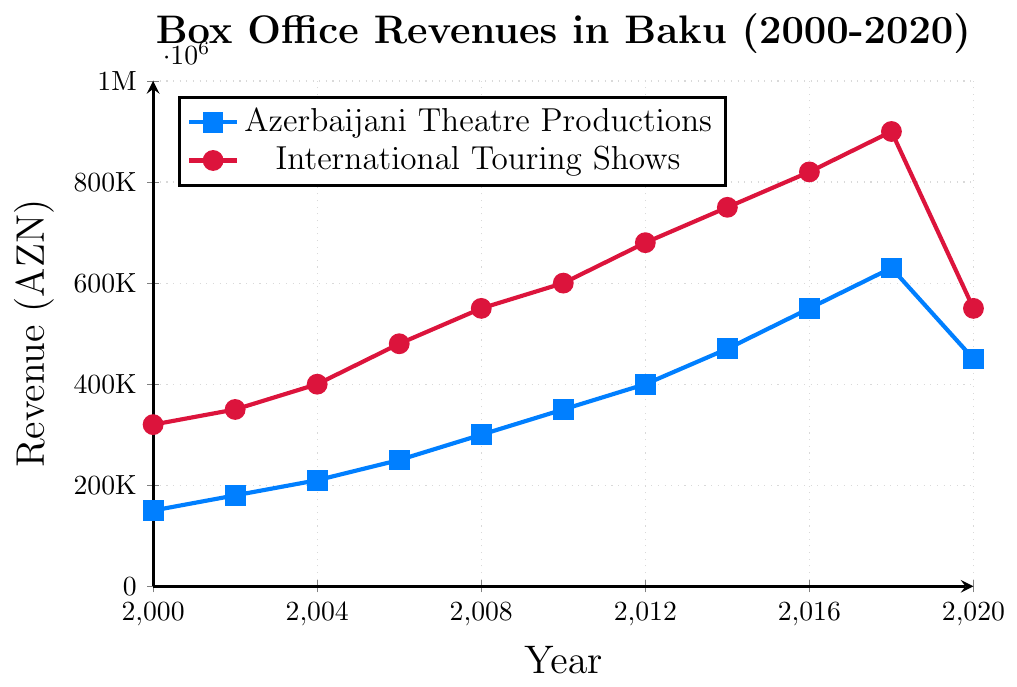How did the box office revenue for Azerbaijani theatre productions change from 2000 to 2020? In 2000, the revenue was 150,000 AZN, and by 2020 it had increased to 450,000 AZN. This is a change of 450,000 - 150,000 = 300,000 AZN.
Answer: Increased by 300,000 AZN Which year saw the highest revenue for Azerbaijani theatre productions? From the chart, we see that the highest revenue for Azerbaijani theatre productions is in 2018, which was 630,000 AZN.
Answer: 2018 In which year did both Azerbaijani theatre productions and international touring shows have the lowest combined revenue? To find this, we need to sum the revenues for both in each year:  
2000: 150,000 + 320,000 = 470,000  
2002: 180,000 + 350,000 = 530,000  
2004: 210,000 + 400,000 = 610,000  
2006: 250,000 + 480,000 = 730,000  
2008: 300,000 + 550,000 = 850,000  
2010: 350,000 + 600,000 = 950,000  
2012: 400,000 + 680,000 = 1,080,000  
2014: 470,000 + 750,000 = 1,220,000  
2016: 550,000 + 820,000 = 1,370,000  
2018: 630,000 + 900,000 = 1,530,000  
2020: 450,000 + 550,000 = 1,000,000  
The lowest combined revenue was in 2000, with 470,000 AZN.
Answer: 2000 Compare the trends of box office revenues for Azerbaijani theatre productions and international touring shows from 2000 to 2020. The chart shows that both revenues generally increased from 2000 to 2018. However, while Azerbaijani theatre productions had a significant dip in 2020, international touring shows also dropped but remained higher than Azerbaijani productions.
Answer: Both increased until 2018, then decreased in 2020 What was the percentage increase in revenue from 2000 to 2018 for Azerbaijani theatre productions? In 2000, the revenue was 150,000 AZN, and in 2018 it was 630,000 AZN. The increase is 630,000 - 150,000 = 480,000 AZN. The percentage increase is (480,000 / 150,000) * 100 = 320%.
Answer: 320% Which year had the largest difference in box office revenue between Azerbaijani theatre productions and international touring shows? To find this, we need to subtract Azerbaijani theatre production revenue from international touring show revenue for each year:
2000: 320,000 - 150,000 = 170,000  
2002: 350,000 - 180,000 = 170,000  
2004: 400,000 - 210,000 = 190,000  
2006: 480,000 - 250,000 = 230,000  
2008: 550,000 - 300,000 = 250,000  
2010: 600,000 - 350,000 = 250,000  
2012: 680,000 - 400,000 = 280,000  
2014: 750,000 - 470,000 = 280,000  
2016: 820,000 - 550,000 = 270,000  
2018: 900,000 - 630,000 = 270,000  
2020: 550,000 - 450,000 = 100,000  
The largest difference was in 2012 and 2014, both at 280,000 AZN.
Answer: 2012 and 2014 What can you infer about the impact of external factors on the box office revenues in 2020? Both Azerbaijani theatre productions and international touring shows saw a significant decline in their revenues in 2020 compared to 2018. This likely indicates an external factor such as the COVID-19 pandemic affected the box office revenues.
Answer: Possible impact of COVID-19 pandemic 